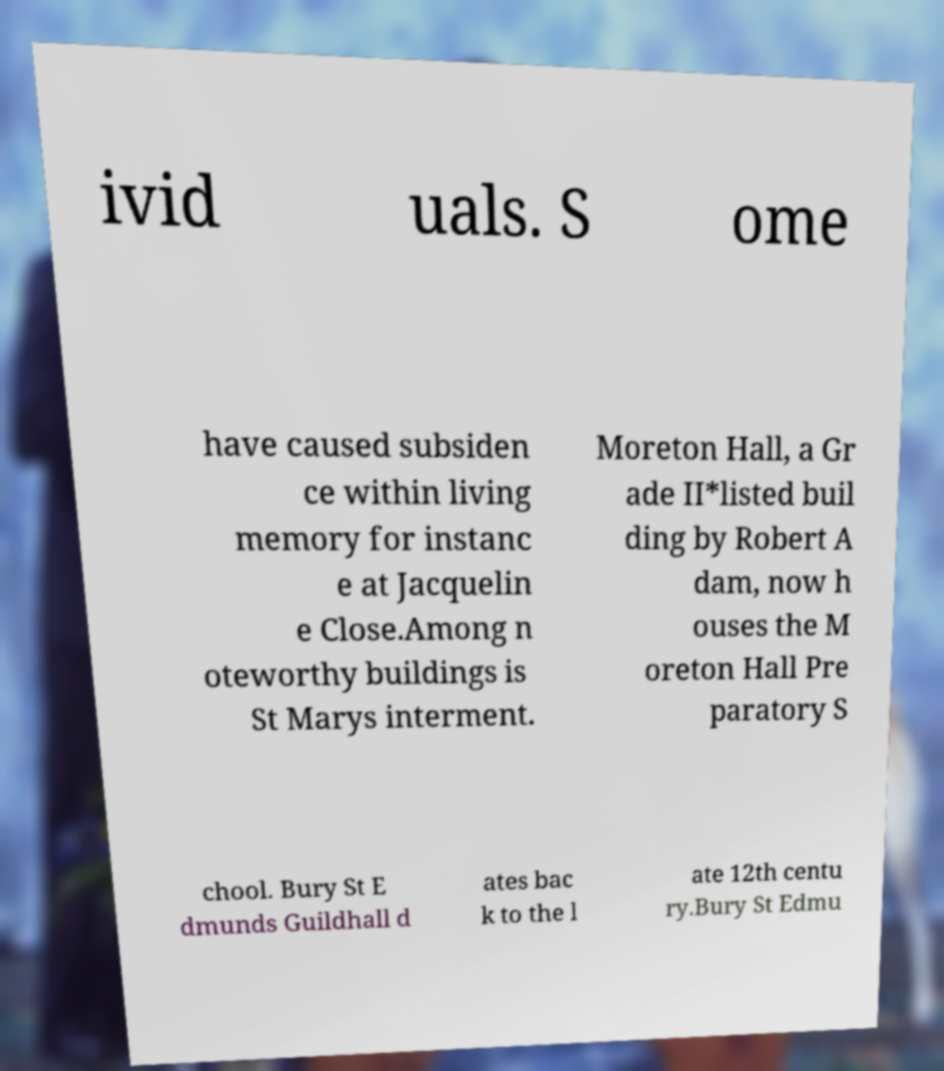What messages or text are displayed in this image? I need them in a readable, typed format. ivid uals. S ome have caused subsiden ce within living memory for instanc e at Jacquelin e Close.Among n oteworthy buildings is St Marys interment. Moreton Hall, a Gr ade II*listed buil ding by Robert A dam, now h ouses the M oreton Hall Pre paratory S chool. Bury St E dmunds Guildhall d ates bac k to the l ate 12th centu ry.Bury St Edmu 